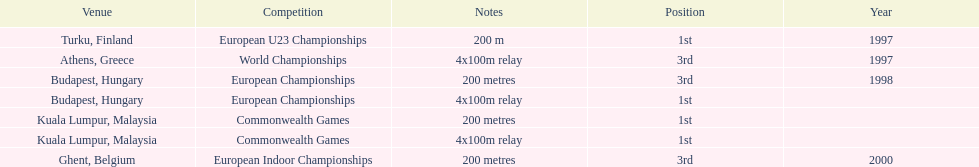How many 4x 100m relays were run? 3. 